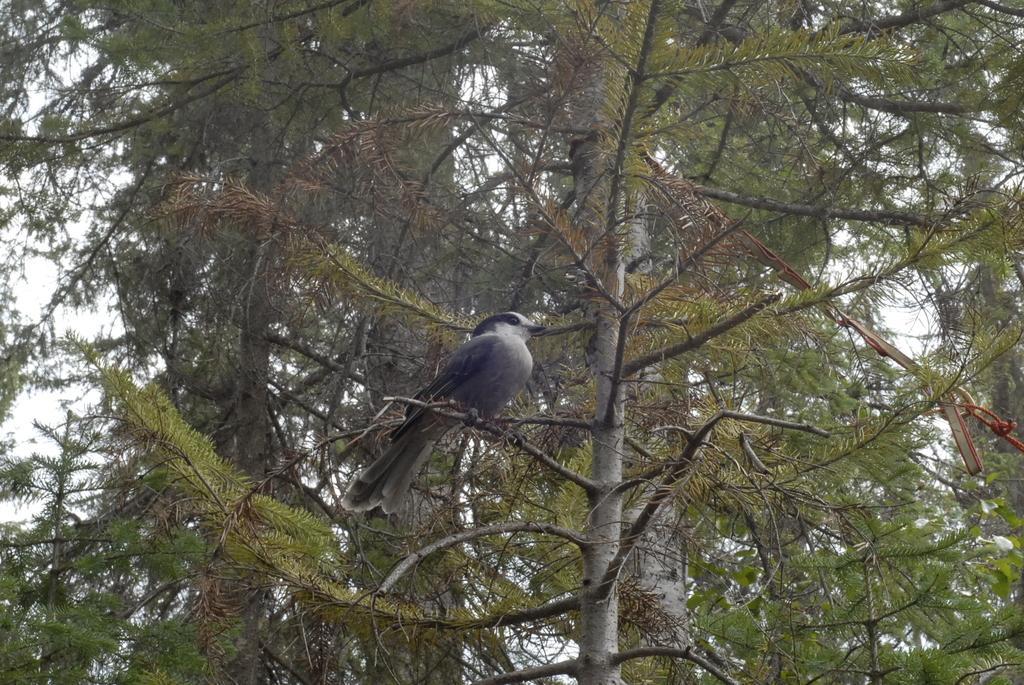Can you describe this image briefly? In this picture there is a bird in the center of the image on a stem and there is a tree in the background area of the image. 